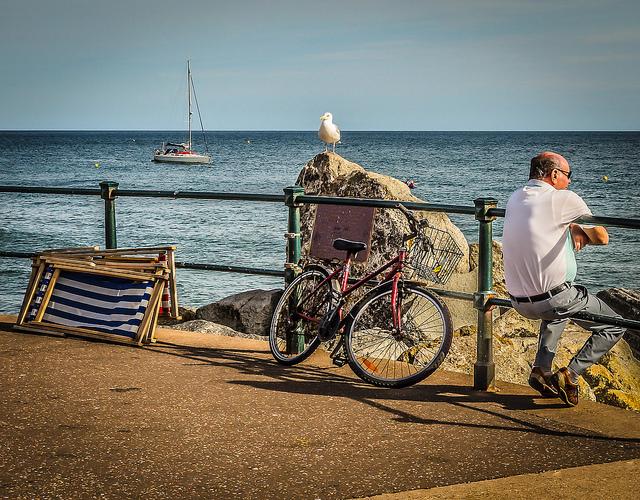How many boats are in the water?
Be succinct. 1. Is the man sitting or standing on the railing?
Short answer required. Sitting. What else is present?
Answer briefly. Seagull. 